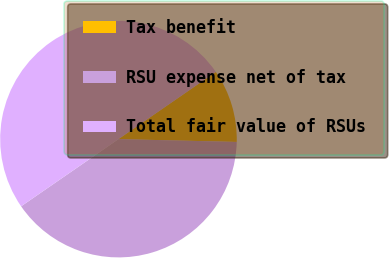Convert chart to OTSL. <chart><loc_0><loc_0><loc_500><loc_500><pie_chart><fcel>Tax benefit<fcel>RSU expense net of tax<fcel>Total fair value of RSUs<nl><fcel>10.0%<fcel>40.0%<fcel>50.0%<nl></chart> 